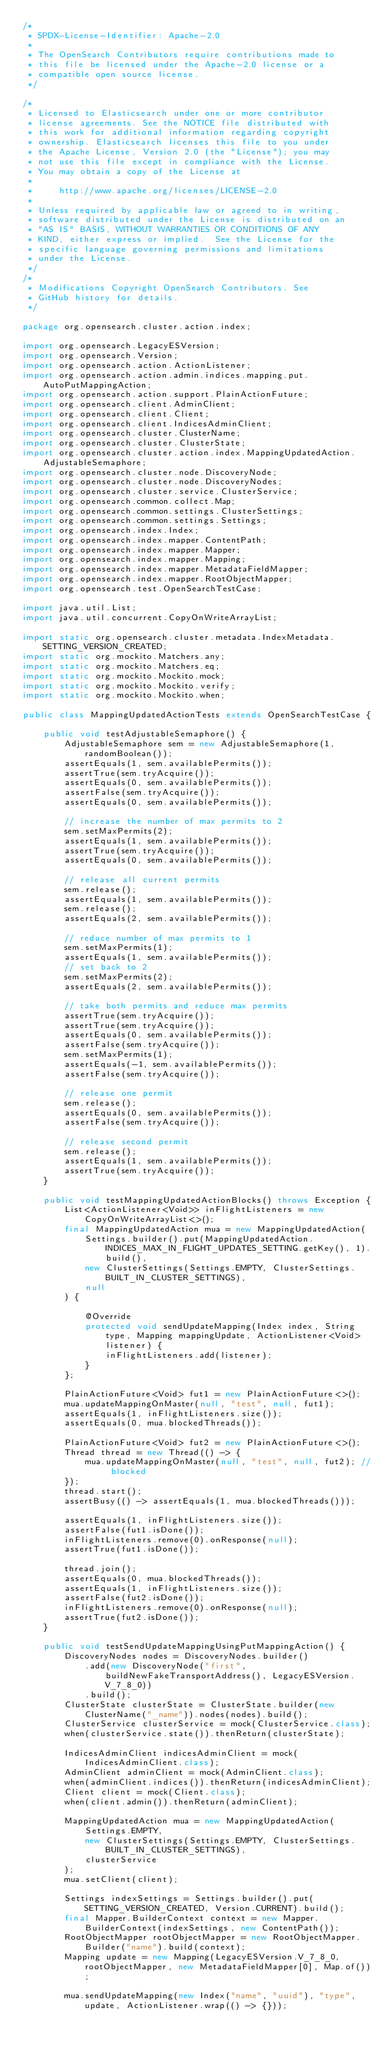<code> <loc_0><loc_0><loc_500><loc_500><_Java_>/*
 * SPDX-License-Identifier: Apache-2.0
 *
 * The OpenSearch Contributors require contributions made to
 * this file be licensed under the Apache-2.0 license or a
 * compatible open source license.
 */

/*
 * Licensed to Elasticsearch under one or more contributor
 * license agreements. See the NOTICE file distributed with
 * this work for additional information regarding copyright
 * ownership. Elasticsearch licenses this file to you under
 * the Apache License, Version 2.0 (the "License"); you may
 * not use this file except in compliance with the License.
 * You may obtain a copy of the License at
 *
 *     http://www.apache.org/licenses/LICENSE-2.0
 *
 * Unless required by applicable law or agreed to in writing,
 * software distributed under the License is distributed on an
 * "AS IS" BASIS, WITHOUT WARRANTIES OR CONDITIONS OF ANY
 * KIND, either express or implied.  See the License for the
 * specific language governing permissions and limitations
 * under the License.
 */
/*
 * Modifications Copyright OpenSearch Contributors. See
 * GitHub history for details.
 */

package org.opensearch.cluster.action.index;

import org.opensearch.LegacyESVersion;
import org.opensearch.Version;
import org.opensearch.action.ActionListener;
import org.opensearch.action.admin.indices.mapping.put.AutoPutMappingAction;
import org.opensearch.action.support.PlainActionFuture;
import org.opensearch.client.AdminClient;
import org.opensearch.client.Client;
import org.opensearch.client.IndicesAdminClient;
import org.opensearch.cluster.ClusterName;
import org.opensearch.cluster.ClusterState;
import org.opensearch.cluster.action.index.MappingUpdatedAction.AdjustableSemaphore;
import org.opensearch.cluster.node.DiscoveryNode;
import org.opensearch.cluster.node.DiscoveryNodes;
import org.opensearch.cluster.service.ClusterService;
import org.opensearch.common.collect.Map;
import org.opensearch.common.settings.ClusterSettings;
import org.opensearch.common.settings.Settings;
import org.opensearch.index.Index;
import org.opensearch.index.mapper.ContentPath;
import org.opensearch.index.mapper.Mapper;
import org.opensearch.index.mapper.Mapping;
import org.opensearch.index.mapper.MetadataFieldMapper;
import org.opensearch.index.mapper.RootObjectMapper;
import org.opensearch.test.OpenSearchTestCase;

import java.util.List;
import java.util.concurrent.CopyOnWriteArrayList;

import static org.opensearch.cluster.metadata.IndexMetadata.SETTING_VERSION_CREATED;
import static org.mockito.Matchers.any;
import static org.mockito.Matchers.eq;
import static org.mockito.Mockito.mock;
import static org.mockito.Mockito.verify;
import static org.mockito.Mockito.when;

public class MappingUpdatedActionTests extends OpenSearchTestCase {

    public void testAdjustableSemaphore() {
        AdjustableSemaphore sem = new AdjustableSemaphore(1, randomBoolean());
        assertEquals(1, sem.availablePermits());
        assertTrue(sem.tryAcquire());
        assertEquals(0, sem.availablePermits());
        assertFalse(sem.tryAcquire());
        assertEquals(0, sem.availablePermits());

        // increase the number of max permits to 2
        sem.setMaxPermits(2);
        assertEquals(1, sem.availablePermits());
        assertTrue(sem.tryAcquire());
        assertEquals(0, sem.availablePermits());

        // release all current permits
        sem.release();
        assertEquals(1, sem.availablePermits());
        sem.release();
        assertEquals(2, sem.availablePermits());

        // reduce number of max permits to 1
        sem.setMaxPermits(1);
        assertEquals(1, sem.availablePermits());
        // set back to 2
        sem.setMaxPermits(2);
        assertEquals(2, sem.availablePermits());

        // take both permits and reduce max permits
        assertTrue(sem.tryAcquire());
        assertTrue(sem.tryAcquire());
        assertEquals(0, sem.availablePermits());
        assertFalse(sem.tryAcquire());
        sem.setMaxPermits(1);
        assertEquals(-1, sem.availablePermits());
        assertFalse(sem.tryAcquire());

        // release one permit
        sem.release();
        assertEquals(0, sem.availablePermits());
        assertFalse(sem.tryAcquire());

        // release second permit
        sem.release();
        assertEquals(1, sem.availablePermits());
        assertTrue(sem.tryAcquire());
    }

    public void testMappingUpdatedActionBlocks() throws Exception {
        List<ActionListener<Void>> inFlightListeners = new CopyOnWriteArrayList<>();
        final MappingUpdatedAction mua = new MappingUpdatedAction(
            Settings.builder().put(MappingUpdatedAction.INDICES_MAX_IN_FLIGHT_UPDATES_SETTING.getKey(), 1).build(),
            new ClusterSettings(Settings.EMPTY, ClusterSettings.BUILT_IN_CLUSTER_SETTINGS),
            null
        ) {

            @Override
            protected void sendUpdateMapping(Index index, String type, Mapping mappingUpdate, ActionListener<Void> listener) {
                inFlightListeners.add(listener);
            }
        };

        PlainActionFuture<Void> fut1 = new PlainActionFuture<>();
        mua.updateMappingOnMaster(null, "test", null, fut1);
        assertEquals(1, inFlightListeners.size());
        assertEquals(0, mua.blockedThreads());

        PlainActionFuture<Void> fut2 = new PlainActionFuture<>();
        Thread thread = new Thread(() -> {
            mua.updateMappingOnMaster(null, "test", null, fut2); // blocked
        });
        thread.start();
        assertBusy(() -> assertEquals(1, mua.blockedThreads()));

        assertEquals(1, inFlightListeners.size());
        assertFalse(fut1.isDone());
        inFlightListeners.remove(0).onResponse(null);
        assertTrue(fut1.isDone());

        thread.join();
        assertEquals(0, mua.blockedThreads());
        assertEquals(1, inFlightListeners.size());
        assertFalse(fut2.isDone());
        inFlightListeners.remove(0).onResponse(null);
        assertTrue(fut2.isDone());
    }

    public void testSendUpdateMappingUsingPutMappingAction() {
        DiscoveryNodes nodes = DiscoveryNodes.builder()
            .add(new DiscoveryNode("first", buildNewFakeTransportAddress(), LegacyESVersion.V_7_8_0))
            .build();
        ClusterState clusterState = ClusterState.builder(new ClusterName("_name")).nodes(nodes).build();
        ClusterService clusterService = mock(ClusterService.class);
        when(clusterService.state()).thenReturn(clusterState);

        IndicesAdminClient indicesAdminClient = mock(IndicesAdminClient.class);
        AdminClient adminClient = mock(AdminClient.class);
        when(adminClient.indices()).thenReturn(indicesAdminClient);
        Client client = mock(Client.class);
        when(client.admin()).thenReturn(adminClient);

        MappingUpdatedAction mua = new MappingUpdatedAction(
            Settings.EMPTY,
            new ClusterSettings(Settings.EMPTY, ClusterSettings.BUILT_IN_CLUSTER_SETTINGS),
            clusterService
        );
        mua.setClient(client);

        Settings indexSettings = Settings.builder().put(SETTING_VERSION_CREATED, Version.CURRENT).build();
        final Mapper.BuilderContext context = new Mapper.BuilderContext(indexSettings, new ContentPath());
        RootObjectMapper rootObjectMapper = new RootObjectMapper.Builder("name").build(context);
        Mapping update = new Mapping(LegacyESVersion.V_7_8_0, rootObjectMapper, new MetadataFieldMapper[0], Map.of());

        mua.sendUpdateMapping(new Index("name", "uuid"), "type", update, ActionListener.wrap(() -> {}));</code> 